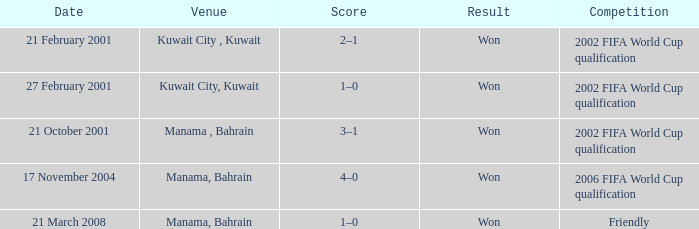On which date was the match in Manama, Bahrain? 21 October 2001, 17 November 2004, 21 March 2008. 